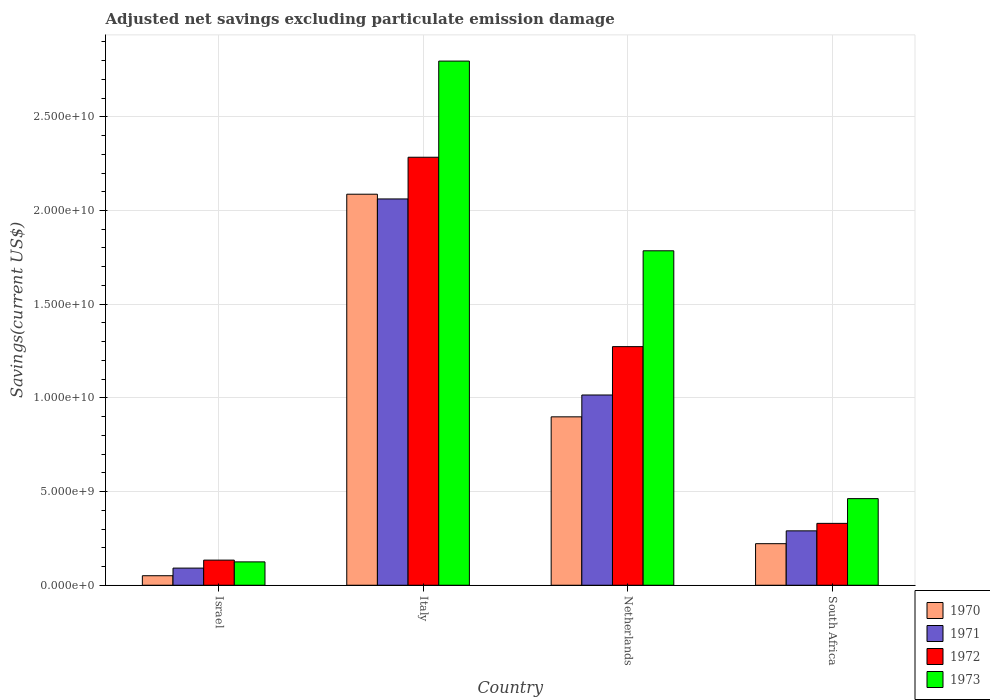How many different coloured bars are there?
Make the answer very short. 4. Are the number of bars per tick equal to the number of legend labels?
Your answer should be very brief. Yes. Are the number of bars on each tick of the X-axis equal?
Your answer should be compact. Yes. How many bars are there on the 4th tick from the left?
Give a very brief answer. 4. How many bars are there on the 3rd tick from the right?
Ensure brevity in your answer.  4. What is the adjusted net savings in 1972 in Italy?
Provide a succinct answer. 2.28e+1. Across all countries, what is the maximum adjusted net savings in 1970?
Your response must be concise. 2.09e+1. Across all countries, what is the minimum adjusted net savings in 1970?
Your response must be concise. 5.08e+08. In which country was the adjusted net savings in 1972 minimum?
Ensure brevity in your answer.  Israel. What is the total adjusted net savings in 1971 in the graph?
Your response must be concise. 3.46e+1. What is the difference between the adjusted net savings in 1970 in Israel and that in Netherlands?
Make the answer very short. -8.48e+09. What is the difference between the adjusted net savings in 1970 in South Africa and the adjusted net savings in 1972 in Italy?
Offer a very short reply. -2.06e+1. What is the average adjusted net savings in 1970 per country?
Offer a terse response. 8.15e+09. What is the difference between the adjusted net savings of/in 1970 and adjusted net savings of/in 1972 in Italy?
Your response must be concise. -1.97e+09. In how many countries, is the adjusted net savings in 1973 greater than 12000000000 US$?
Provide a short and direct response. 2. What is the ratio of the adjusted net savings in 1973 in Israel to that in South Africa?
Provide a short and direct response. 0.27. Is the difference between the adjusted net savings in 1970 in Netherlands and South Africa greater than the difference between the adjusted net savings in 1972 in Netherlands and South Africa?
Provide a short and direct response. No. What is the difference between the highest and the second highest adjusted net savings in 1971?
Ensure brevity in your answer.  -1.77e+1. What is the difference between the highest and the lowest adjusted net savings in 1970?
Give a very brief answer. 2.04e+1. What does the 3rd bar from the left in Italy represents?
Your answer should be very brief. 1972. Are the values on the major ticks of Y-axis written in scientific E-notation?
Provide a short and direct response. Yes. Does the graph contain grids?
Give a very brief answer. Yes. Where does the legend appear in the graph?
Provide a short and direct response. Bottom right. What is the title of the graph?
Your answer should be very brief. Adjusted net savings excluding particulate emission damage. What is the label or title of the Y-axis?
Ensure brevity in your answer.  Savings(current US$). What is the Savings(current US$) of 1970 in Israel?
Offer a very short reply. 5.08e+08. What is the Savings(current US$) of 1971 in Israel?
Make the answer very short. 9.14e+08. What is the Savings(current US$) in 1972 in Israel?
Keep it short and to the point. 1.34e+09. What is the Savings(current US$) in 1973 in Israel?
Offer a very short reply. 1.25e+09. What is the Savings(current US$) of 1970 in Italy?
Offer a terse response. 2.09e+1. What is the Savings(current US$) in 1971 in Italy?
Make the answer very short. 2.06e+1. What is the Savings(current US$) in 1972 in Italy?
Ensure brevity in your answer.  2.28e+1. What is the Savings(current US$) of 1973 in Italy?
Keep it short and to the point. 2.80e+1. What is the Savings(current US$) of 1970 in Netherlands?
Provide a succinct answer. 8.99e+09. What is the Savings(current US$) in 1971 in Netherlands?
Your response must be concise. 1.02e+1. What is the Savings(current US$) of 1972 in Netherlands?
Keep it short and to the point. 1.27e+1. What is the Savings(current US$) of 1973 in Netherlands?
Keep it short and to the point. 1.79e+1. What is the Savings(current US$) of 1970 in South Africa?
Give a very brief answer. 2.22e+09. What is the Savings(current US$) in 1971 in South Africa?
Offer a terse response. 2.90e+09. What is the Savings(current US$) of 1972 in South Africa?
Ensure brevity in your answer.  3.30e+09. What is the Savings(current US$) in 1973 in South Africa?
Your answer should be very brief. 4.62e+09. Across all countries, what is the maximum Savings(current US$) in 1970?
Offer a terse response. 2.09e+1. Across all countries, what is the maximum Savings(current US$) of 1971?
Offer a very short reply. 2.06e+1. Across all countries, what is the maximum Savings(current US$) of 1972?
Your answer should be very brief. 2.28e+1. Across all countries, what is the maximum Savings(current US$) of 1973?
Provide a short and direct response. 2.80e+1. Across all countries, what is the minimum Savings(current US$) of 1970?
Offer a terse response. 5.08e+08. Across all countries, what is the minimum Savings(current US$) of 1971?
Give a very brief answer. 9.14e+08. Across all countries, what is the minimum Savings(current US$) in 1972?
Your response must be concise. 1.34e+09. Across all countries, what is the minimum Savings(current US$) in 1973?
Your answer should be compact. 1.25e+09. What is the total Savings(current US$) of 1970 in the graph?
Keep it short and to the point. 3.26e+1. What is the total Savings(current US$) of 1971 in the graph?
Give a very brief answer. 3.46e+1. What is the total Savings(current US$) of 1972 in the graph?
Offer a very short reply. 4.02e+1. What is the total Savings(current US$) of 1973 in the graph?
Give a very brief answer. 5.17e+1. What is the difference between the Savings(current US$) in 1970 in Israel and that in Italy?
Your answer should be very brief. -2.04e+1. What is the difference between the Savings(current US$) in 1971 in Israel and that in Italy?
Ensure brevity in your answer.  -1.97e+1. What is the difference between the Savings(current US$) of 1972 in Israel and that in Italy?
Provide a short and direct response. -2.15e+1. What is the difference between the Savings(current US$) in 1973 in Israel and that in Italy?
Give a very brief answer. -2.67e+1. What is the difference between the Savings(current US$) in 1970 in Israel and that in Netherlands?
Give a very brief answer. -8.48e+09. What is the difference between the Savings(current US$) of 1971 in Israel and that in Netherlands?
Offer a very short reply. -9.24e+09. What is the difference between the Savings(current US$) of 1972 in Israel and that in Netherlands?
Your answer should be compact. -1.14e+1. What is the difference between the Savings(current US$) in 1973 in Israel and that in Netherlands?
Offer a terse response. -1.66e+1. What is the difference between the Savings(current US$) of 1970 in Israel and that in South Africa?
Keep it short and to the point. -1.71e+09. What is the difference between the Savings(current US$) of 1971 in Israel and that in South Africa?
Keep it short and to the point. -1.99e+09. What is the difference between the Savings(current US$) in 1972 in Israel and that in South Africa?
Your answer should be compact. -1.96e+09. What is the difference between the Savings(current US$) in 1973 in Israel and that in South Africa?
Make the answer very short. -3.38e+09. What is the difference between the Savings(current US$) in 1970 in Italy and that in Netherlands?
Offer a terse response. 1.19e+1. What is the difference between the Savings(current US$) of 1971 in Italy and that in Netherlands?
Your answer should be very brief. 1.05e+1. What is the difference between the Savings(current US$) in 1972 in Italy and that in Netherlands?
Provide a succinct answer. 1.01e+1. What is the difference between the Savings(current US$) of 1973 in Italy and that in Netherlands?
Ensure brevity in your answer.  1.01e+1. What is the difference between the Savings(current US$) of 1970 in Italy and that in South Africa?
Make the answer very short. 1.87e+1. What is the difference between the Savings(current US$) of 1971 in Italy and that in South Africa?
Make the answer very short. 1.77e+1. What is the difference between the Savings(current US$) in 1972 in Italy and that in South Africa?
Your answer should be very brief. 1.95e+1. What is the difference between the Savings(current US$) of 1973 in Italy and that in South Africa?
Offer a terse response. 2.34e+1. What is the difference between the Savings(current US$) in 1970 in Netherlands and that in South Africa?
Offer a terse response. 6.77e+09. What is the difference between the Savings(current US$) of 1971 in Netherlands and that in South Africa?
Your response must be concise. 7.25e+09. What is the difference between the Savings(current US$) in 1972 in Netherlands and that in South Africa?
Keep it short and to the point. 9.43e+09. What is the difference between the Savings(current US$) in 1973 in Netherlands and that in South Africa?
Give a very brief answer. 1.32e+1. What is the difference between the Savings(current US$) in 1970 in Israel and the Savings(current US$) in 1971 in Italy?
Ensure brevity in your answer.  -2.01e+1. What is the difference between the Savings(current US$) in 1970 in Israel and the Savings(current US$) in 1972 in Italy?
Make the answer very short. -2.23e+1. What is the difference between the Savings(current US$) in 1970 in Israel and the Savings(current US$) in 1973 in Italy?
Keep it short and to the point. -2.75e+1. What is the difference between the Savings(current US$) in 1971 in Israel and the Savings(current US$) in 1972 in Italy?
Your response must be concise. -2.19e+1. What is the difference between the Savings(current US$) of 1971 in Israel and the Savings(current US$) of 1973 in Italy?
Provide a succinct answer. -2.71e+1. What is the difference between the Savings(current US$) in 1972 in Israel and the Savings(current US$) in 1973 in Italy?
Give a very brief answer. -2.66e+1. What is the difference between the Savings(current US$) of 1970 in Israel and the Savings(current US$) of 1971 in Netherlands?
Provide a succinct answer. -9.65e+09. What is the difference between the Savings(current US$) of 1970 in Israel and the Savings(current US$) of 1972 in Netherlands?
Your answer should be very brief. -1.22e+1. What is the difference between the Savings(current US$) of 1970 in Israel and the Savings(current US$) of 1973 in Netherlands?
Provide a succinct answer. -1.73e+1. What is the difference between the Savings(current US$) of 1971 in Israel and the Savings(current US$) of 1972 in Netherlands?
Ensure brevity in your answer.  -1.18e+1. What is the difference between the Savings(current US$) in 1971 in Israel and the Savings(current US$) in 1973 in Netherlands?
Provide a short and direct response. -1.69e+1. What is the difference between the Savings(current US$) of 1972 in Israel and the Savings(current US$) of 1973 in Netherlands?
Provide a succinct answer. -1.65e+1. What is the difference between the Savings(current US$) in 1970 in Israel and the Savings(current US$) in 1971 in South Africa?
Offer a terse response. -2.39e+09. What is the difference between the Savings(current US$) of 1970 in Israel and the Savings(current US$) of 1972 in South Africa?
Make the answer very short. -2.79e+09. What is the difference between the Savings(current US$) in 1970 in Israel and the Savings(current US$) in 1973 in South Africa?
Ensure brevity in your answer.  -4.11e+09. What is the difference between the Savings(current US$) in 1971 in Israel and the Savings(current US$) in 1972 in South Africa?
Keep it short and to the point. -2.39e+09. What is the difference between the Savings(current US$) of 1971 in Israel and the Savings(current US$) of 1973 in South Africa?
Your answer should be compact. -3.71e+09. What is the difference between the Savings(current US$) in 1972 in Israel and the Savings(current US$) in 1973 in South Africa?
Provide a short and direct response. -3.28e+09. What is the difference between the Savings(current US$) of 1970 in Italy and the Savings(current US$) of 1971 in Netherlands?
Ensure brevity in your answer.  1.07e+1. What is the difference between the Savings(current US$) of 1970 in Italy and the Savings(current US$) of 1972 in Netherlands?
Ensure brevity in your answer.  8.14e+09. What is the difference between the Savings(current US$) of 1970 in Italy and the Savings(current US$) of 1973 in Netherlands?
Your response must be concise. 3.02e+09. What is the difference between the Savings(current US$) of 1971 in Italy and the Savings(current US$) of 1972 in Netherlands?
Your answer should be very brief. 7.88e+09. What is the difference between the Savings(current US$) of 1971 in Italy and the Savings(current US$) of 1973 in Netherlands?
Ensure brevity in your answer.  2.77e+09. What is the difference between the Savings(current US$) of 1972 in Italy and the Savings(current US$) of 1973 in Netherlands?
Your answer should be compact. 4.99e+09. What is the difference between the Savings(current US$) of 1970 in Italy and the Savings(current US$) of 1971 in South Africa?
Ensure brevity in your answer.  1.80e+1. What is the difference between the Savings(current US$) in 1970 in Italy and the Savings(current US$) in 1972 in South Africa?
Your answer should be compact. 1.76e+1. What is the difference between the Savings(current US$) in 1970 in Italy and the Savings(current US$) in 1973 in South Africa?
Offer a terse response. 1.62e+1. What is the difference between the Savings(current US$) of 1971 in Italy and the Savings(current US$) of 1972 in South Africa?
Offer a terse response. 1.73e+1. What is the difference between the Savings(current US$) of 1971 in Italy and the Savings(current US$) of 1973 in South Africa?
Offer a very short reply. 1.60e+1. What is the difference between the Savings(current US$) in 1972 in Italy and the Savings(current US$) in 1973 in South Africa?
Ensure brevity in your answer.  1.82e+1. What is the difference between the Savings(current US$) of 1970 in Netherlands and the Savings(current US$) of 1971 in South Africa?
Offer a very short reply. 6.09e+09. What is the difference between the Savings(current US$) of 1970 in Netherlands and the Savings(current US$) of 1972 in South Africa?
Provide a succinct answer. 5.69e+09. What is the difference between the Savings(current US$) in 1970 in Netherlands and the Savings(current US$) in 1973 in South Africa?
Offer a very short reply. 4.37e+09. What is the difference between the Savings(current US$) of 1971 in Netherlands and the Savings(current US$) of 1972 in South Africa?
Provide a short and direct response. 6.85e+09. What is the difference between the Savings(current US$) in 1971 in Netherlands and the Savings(current US$) in 1973 in South Africa?
Your answer should be very brief. 5.53e+09. What is the difference between the Savings(current US$) in 1972 in Netherlands and the Savings(current US$) in 1973 in South Africa?
Ensure brevity in your answer.  8.11e+09. What is the average Savings(current US$) in 1970 per country?
Your answer should be very brief. 8.15e+09. What is the average Savings(current US$) of 1971 per country?
Offer a terse response. 8.65e+09. What is the average Savings(current US$) in 1972 per country?
Make the answer very short. 1.01e+1. What is the average Savings(current US$) of 1973 per country?
Your answer should be very brief. 1.29e+1. What is the difference between the Savings(current US$) of 1970 and Savings(current US$) of 1971 in Israel?
Offer a very short reply. -4.06e+08. What is the difference between the Savings(current US$) of 1970 and Savings(current US$) of 1972 in Israel?
Your answer should be very brief. -8.33e+08. What is the difference between the Savings(current US$) of 1970 and Savings(current US$) of 1973 in Israel?
Ensure brevity in your answer.  -7.39e+08. What is the difference between the Savings(current US$) of 1971 and Savings(current US$) of 1972 in Israel?
Ensure brevity in your answer.  -4.27e+08. What is the difference between the Savings(current US$) in 1971 and Savings(current US$) in 1973 in Israel?
Provide a short and direct response. -3.33e+08. What is the difference between the Savings(current US$) in 1972 and Savings(current US$) in 1973 in Israel?
Your answer should be compact. 9.40e+07. What is the difference between the Savings(current US$) in 1970 and Savings(current US$) in 1971 in Italy?
Your response must be concise. 2.53e+08. What is the difference between the Savings(current US$) of 1970 and Savings(current US$) of 1972 in Italy?
Offer a terse response. -1.97e+09. What is the difference between the Savings(current US$) in 1970 and Savings(current US$) in 1973 in Italy?
Offer a terse response. -7.11e+09. What is the difference between the Savings(current US$) of 1971 and Savings(current US$) of 1972 in Italy?
Provide a succinct answer. -2.23e+09. What is the difference between the Savings(current US$) in 1971 and Savings(current US$) in 1973 in Italy?
Offer a terse response. -7.36e+09. What is the difference between the Savings(current US$) in 1972 and Savings(current US$) in 1973 in Italy?
Your response must be concise. -5.13e+09. What is the difference between the Savings(current US$) of 1970 and Savings(current US$) of 1971 in Netherlands?
Provide a short and direct response. -1.17e+09. What is the difference between the Savings(current US$) of 1970 and Savings(current US$) of 1972 in Netherlands?
Ensure brevity in your answer.  -3.75e+09. What is the difference between the Savings(current US$) of 1970 and Savings(current US$) of 1973 in Netherlands?
Ensure brevity in your answer.  -8.86e+09. What is the difference between the Savings(current US$) of 1971 and Savings(current US$) of 1972 in Netherlands?
Provide a short and direct response. -2.58e+09. What is the difference between the Savings(current US$) of 1971 and Savings(current US$) of 1973 in Netherlands?
Offer a terse response. -7.70e+09. What is the difference between the Savings(current US$) of 1972 and Savings(current US$) of 1973 in Netherlands?
Give a very brief answer. -5.11e+09. What is the difference between the Savings(current US$) of 1970 and Savings(current US$) of 1971 in South Africa?
Give a very brief answer. -6.85e+08. What is the difference between the Savings(current US$) of 1970 and Savings(current US$) of 1972 in South Africa?
Your answer should be very brief. -1.08e+09. What is the difference between the Savings(current US$) in 1970 and Savings(current US$) in 1973 in South Africa?
Your response must be concise. -2.40e+09. What is the difference between the Savings(current US$) in 1971 and Savings(current US$) in 1972 in South Africa?
Offer a terse response. -4.00e+08. What is the difference between the Savings(current US$) of 1971 and Savings(current US$) of 1973 in South Africa?
Keep it short and to the point. -1.72e+09. What is the difference between the Savings(current US$) in 1972 and Savings(current US$) in 1973 in South Africa?
Give a very brief answer. -1.32e+09. What is the ratio of the Savings(current US$) in 1970 in Israel to that in Italy?
Offer a very short reply. 0.02. What is the ratio of the Savings(current US$) of 1971 in Israel to that in Italy?
Ensure brevity in your answer.  0.04. What is the ratio of the Savings(current US$) in 1972 in Israel to that in Italy?
Provide a succinct answer. 0.06. What is the ratio of the Savings(current US$) of 1973 in Israel to that in Italy?
Provide a succinct answer. 0.04. What is the ratio of the Savings(current US$) in 1970 in Israel to that in Netherlands?
Keep it short and to the point. 0.06. What is the ratio of the Savings(current US$) of 1971 in Israel to that in Netherlands?
Your answer should be compact. 0.09. What is the ratio of the Savings(current US$) in 1972 in Israel to that in Netherlands?
Make the answer very short. 0.11. What is the ratio of the Savings(current US$) of 1973 in Israel to that in Netherlands?
Offer a terse response. 0.07. What is the ratio of the Savings(current US$) in 1970 in Israel to that in South Africa?
Provide a short and direct response. 0.23. What is the ratio of the Savings(current US$) in 1971 in Israel to that in South Africa?
Ensure brevity in your answer.  0.32. What is the ratio of the Savings(current US$) of 1972 in Israel to that in South Africa?
Offer a terse response. 0.41. What is the ratio of the Savings(current US$) in 1973 in Israel to that in South Africa?
Your response must be concise. 0.27. What is the ratio of the Savings(current US$) in 1970 in Italy to that in Netherlands?
Your response must be concise. 2.32. What is the ratio of the Savings(current US$) in 1971 in Italy to that in Netherlands?
Your response must be concise. 2.03. What is the ratio of the Savings(current US$) of 1972 in Italy to that in Netherlands?
Provide a short and direct response. 1.79. What is the ratio of the Savings(current US$) in 1973 in Italy to that in Netherlands?
Offer a very short reply. 1.57. What is the ratio of the Savings(current US$) in 1970 in Italy to that in South Africa?
Offer a very short reply. 9.41. What is the ratio of the Savings(current US$) in 1971 in Italy to that in South Africa?
Provide a short and direct response. 7.1. What is the ratio of the Savings(current US$) in 1972 in Italy to that in South Africa?
Ensure brevity in your answer.  6.92. What is the ratio of the Savings(current US$) of 1973 in Italy to that in South Africa?
Your response must be concise. 6.05. What is the ratio of the Savings(current US$) of 1970 in Netherlands to that in South Africa?
Give a very brief answer. 4.05. What is the ratio of the Savings(current US$) of 1971 in Netherlands to that in South Africa?
Offer a very short reply. 3.5. What is the ratio of the Savings(current US$) of 1972 in Netherlands to that in South Africa?
Provide a short and direct response. 3.86. What is the ratio of the Savings(current US$) in 1973 in Netherlands to that in South Africa?
Provide a short and direct response. 3.86. What is the difference between the highest and the second highest Savings(current US$) in 1970?
Provide a short and direct response. 1.19e+1. What is the difference between the highest and the second highest Savings(current US$) in 1971?
Ensure brevity in your answer.  1.05e+1. What is the difference between the highest and the second highest Savings(current US$) in 1972?
Make the answer very short. 1.01e+1. What is the difference between the highest and the second highest Savings(current US$) of 1973?
Provide a succinct answer. 1.01e+1. What is the difference between the highest and the lowest Savings(current US$) in 1970?
Provide a succinct answer. 2.04e+1. What is the difference between the highest and the lowest Savings(current US$) of 1971?
Offer a very short reply. 1.97e+1. What is the difference between the highest and the lowest Savings(current US$) in 1972?
Your answer should be compact. 2.15e+1. What is the difference between the highest and the lowest Savings(current US$) of 1973?
Provide a succinct answer. 2.67e+1. 